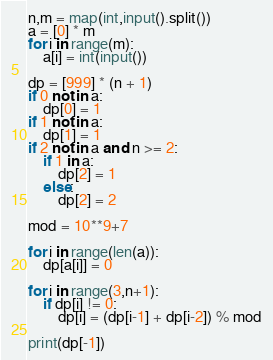Convert code to text. <code><loc_0><loc_0><loc_500><loc_500><_Python_>n,m = map(int,input().split())
a = [0] * m
for i in range(m):
    a[i] = int(input())

dp = [999] * (n + 1)
if 0 not in a:
    dp[0] = 1
if 1 not in a:
    dp[1] = 1
if 2 not in a and n >= 2:
    if 1 in a:
        dp[2] = 1
    else:
        dp[2] = 2

mod = 10**9+7

for i in range(len(a)):
    dp[a[i]] = 0

for i in range(3,n+1):
    if dp[i] != 0:
        dp[i] = (dp[i-1] + dp[i-2]) % mod

print(dp[-1])
</code> 